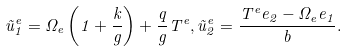<formula> <loc_0><loc_0><loc_500><loc_500>\tilde { u } _ { 1 } ^ { e } = \Omega _ { e } \left ( 1 + \frac { k } { g } \right ) + \frac { q } { g } T ^ { e } , \tilde { u } _ { 2 } ^ { e } = \frac { T ^ { e } e _ { 2 } - \Omega _ { e } e _ { 1 } } { b } .</formula> 